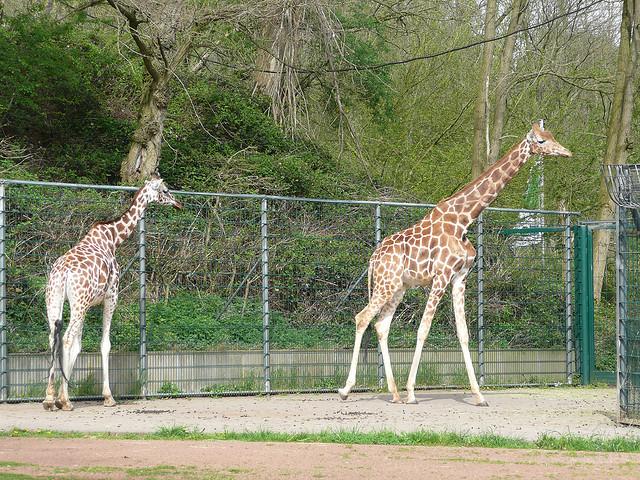Do you think this is in Africa?
Keep it brief. No. Is one giraffe bigger than the other?
Concise answer only. Yes. How tall do you think these giraffes are?
Concise answer only. 12 feet. How many giraffes are in this scene?
Short answer required. 2. How many ostriches are there?
Give a very brief answer. 0. Do the small giraffes have necks?
Give a very brief answer. Yes. How many giraffes are in the picture?
Write a very short answer. 2. Are the giraffes in the wild?
Concise answer only. No. Are the giraffes eating?
Keep it brief. No. How many species are seen?
Answer briefly. 1. 